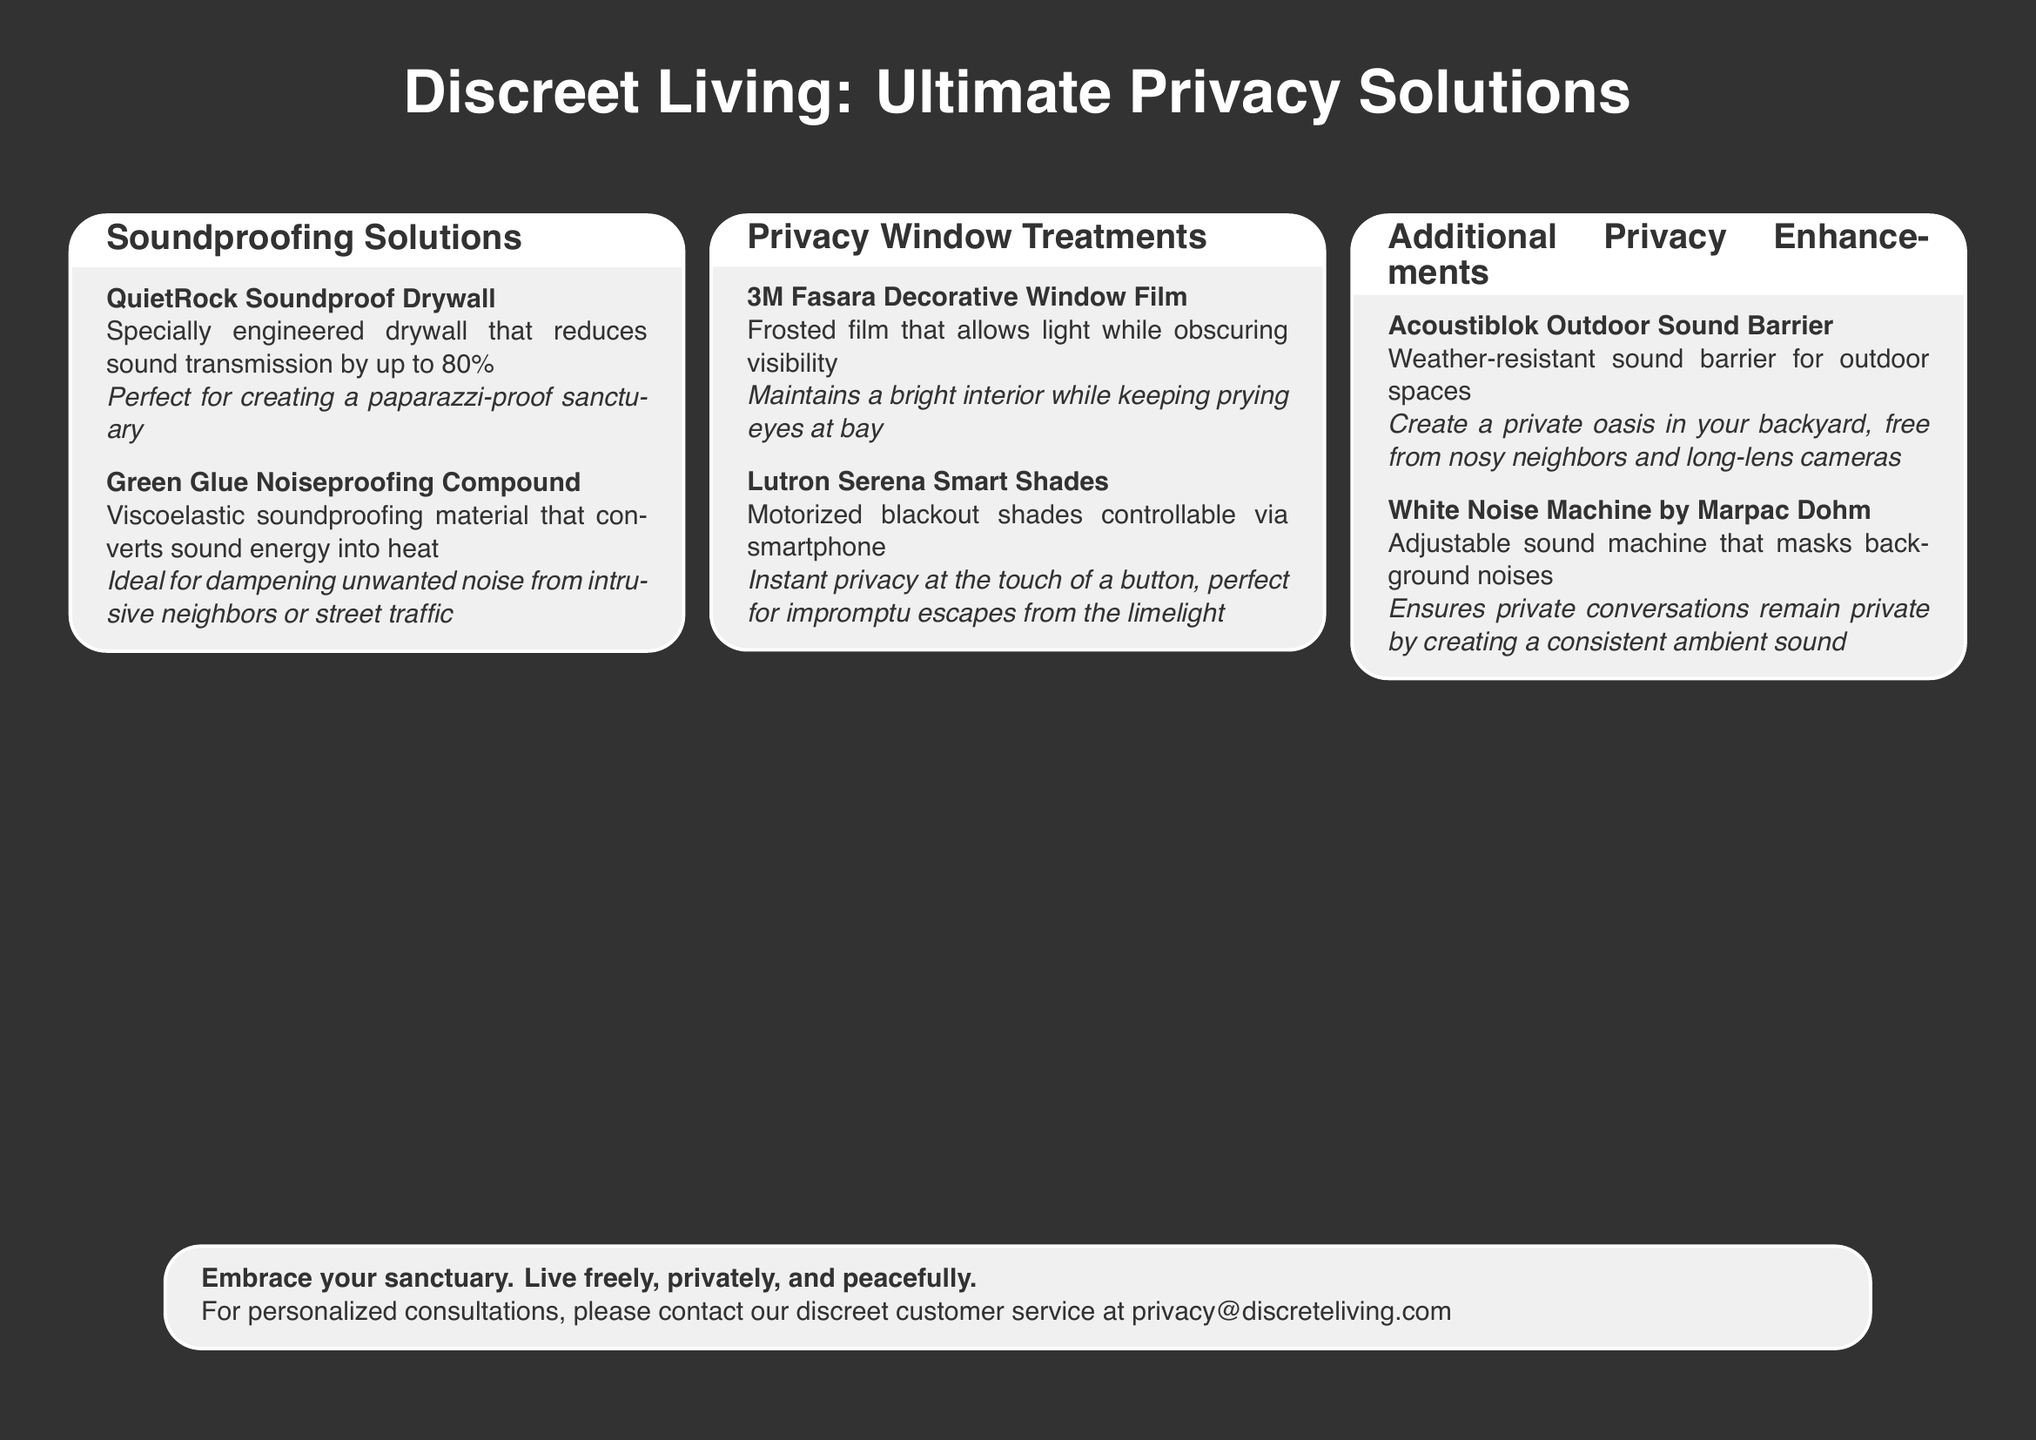What is the product that reduces sound transmission by up to 80%? The product specifically engineered for sound transmission reduction is QuietRock Soundproof Drywall.
Answer: QuietRock Soundproof Drywall What is the ideal use for Green Glue? Green Glue is a viscoelastic soundproofing material that converts sound energy into heat, ideal for dampening unwanted noise.
Answer: Dampening unwanted noise What type of window treatment does Lutron Serena provide? Lutron Serena offers motorized blackout shades that are controllable via smartphone.
Answer: Motorized blackout shades What is the function of the 3M Fasara Decorative Window Film? The 3M Fasara Decorative Window Film allows light while obscuring visibility, maintaining brightness without prying eyes.
Answer: Obscuring visibility What outdoor product creates a private oasis? Acoustiblok Outdoor Sound Barrier is the product designed to create a private oasis in outdoor spaces.
Answer: Acoustiblok Outdoor Sound Barrier Which machine masks background noises? The device that masks background noises is the White Noise Machine by Marpac Dohm.
Answer: White Noise Machine by Marpac Dohm What kind of consultations are offered? The document mentions personalized consultations available via a discrete customer service contact.
Answer: Personalized consultations What color theme does the document predominantly use? The document predominantly uses a dark gray color theme for its background and text.
Answer: Dark gray 